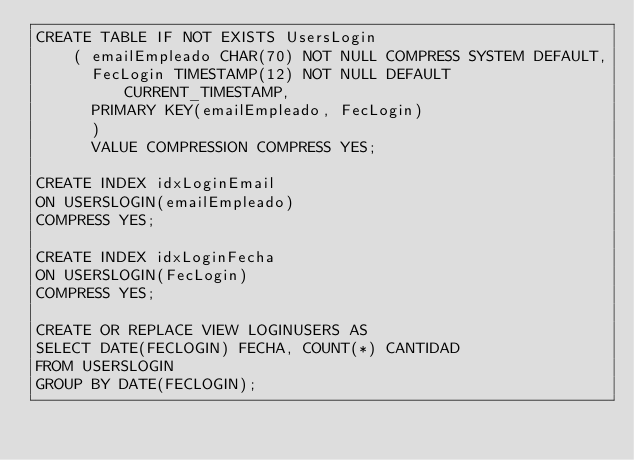Convert code to text. <code><loc_0><loc_0><loc_500><loc_500><_SQL_>CREATE TABLE IF NOT EXISTS UsersLogin 
	( emailEmpleado CHAR(70) NOT NULL COMPRESS SYSTEM DEFAULT,
	  FecLogin TIMESTAMP(12) NOT NULL DEFAULT CURRENT_TIMESTAMP,
	  PRIMARY KEY(emailEmpleado, FecLogin)
	  ) 
	  VALUE COMPRESSION COMPRESS YES;

CREATE INDEX idxLoginEmail
ON USERSLOGIN(emailEmpleado)
COMPRESS YES;

CREATE INDEX idxLoginFecha
ON USERSLOGIN(FecLogin)
COMPRESS YES;

CREATE OR REPLACE VIEW LOGINUSERS AS
SELECT DATE(FECLOGIN) FECHA, COUNT(*) CANTIDAD
FROM USERSLOGIN
GROUP BY DATE(FECLOGIN);
</code> 